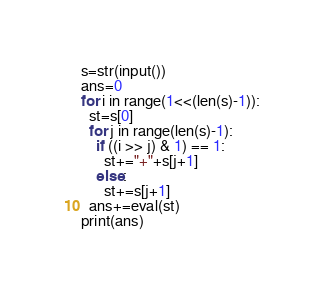Convert code to text. <code><loc_0><loc_0><loc_500><loc_500><_Python_>s=str(input())
ans=0
for i in range(1<<(len(s)-1)):
  st=s[0]
  for j in range(len(s)-1):
    if ((i >> j) & 1) == 1:
      st+="+"+s[j+1]
    else:
      st+=s[j+1]
  ans+=eval(st)
print(ans)
</code> 